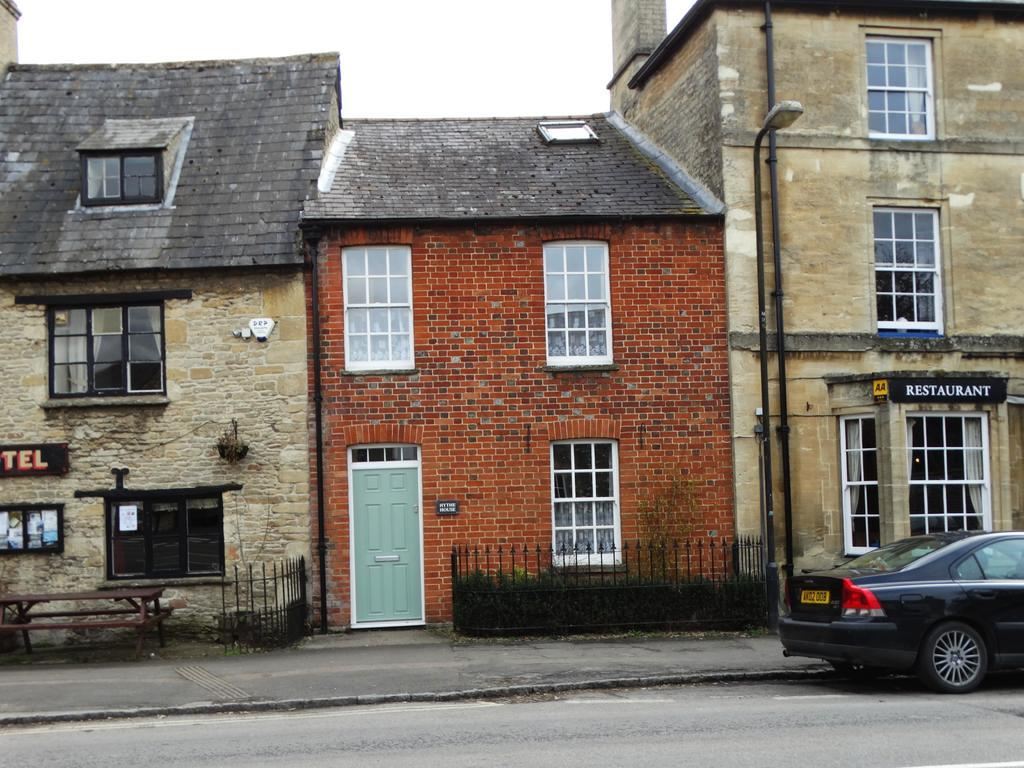What type of structures can be seen in the image? There are houses in the image. Can you describe the scene involving a house and a vehicle? There is a car in front of a house in the image. What type of wool can be seen on the car in the image? There is no wool present on the car in the image. How many zippers can be seen on the houses in the image? There are no zippers present on the houses in the image. 